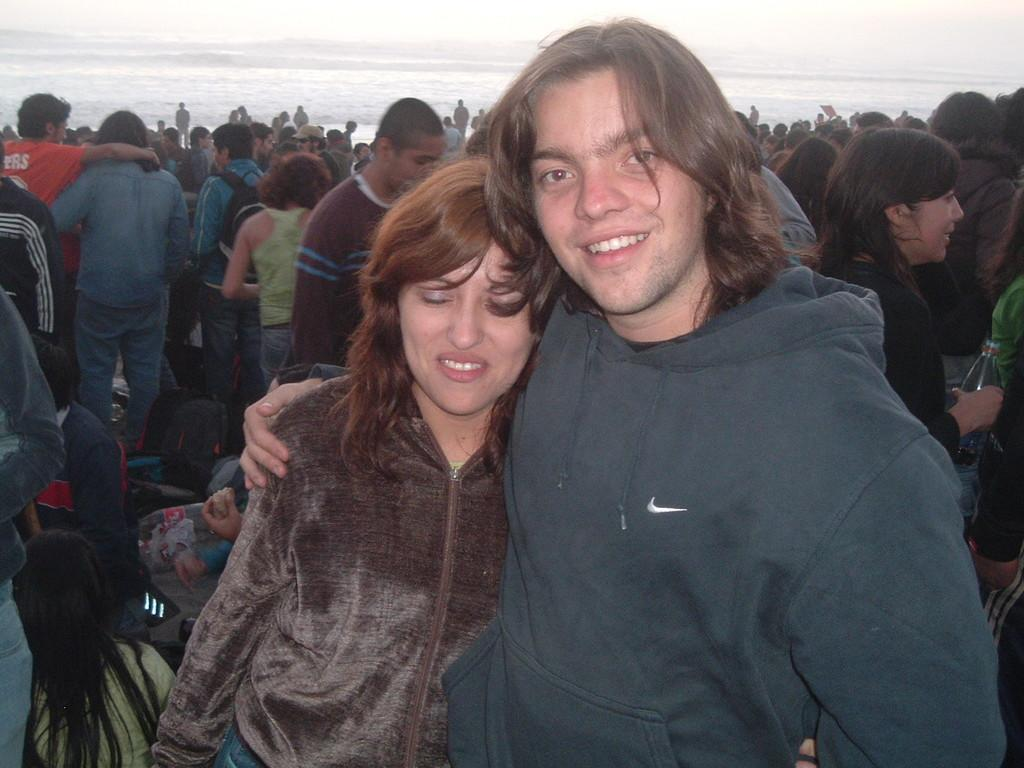How many people are present in the image? There is a man and a woman in the image, making a group of two people. What is the primary setting of the image? The image features a group of people. What can be seen in the background of the image? There is water visible in the background of the image. What type of wealth is being discussed in the meeting in the image? There is no meeting present in the image, and therefore no discussion of wealth can be observed. 